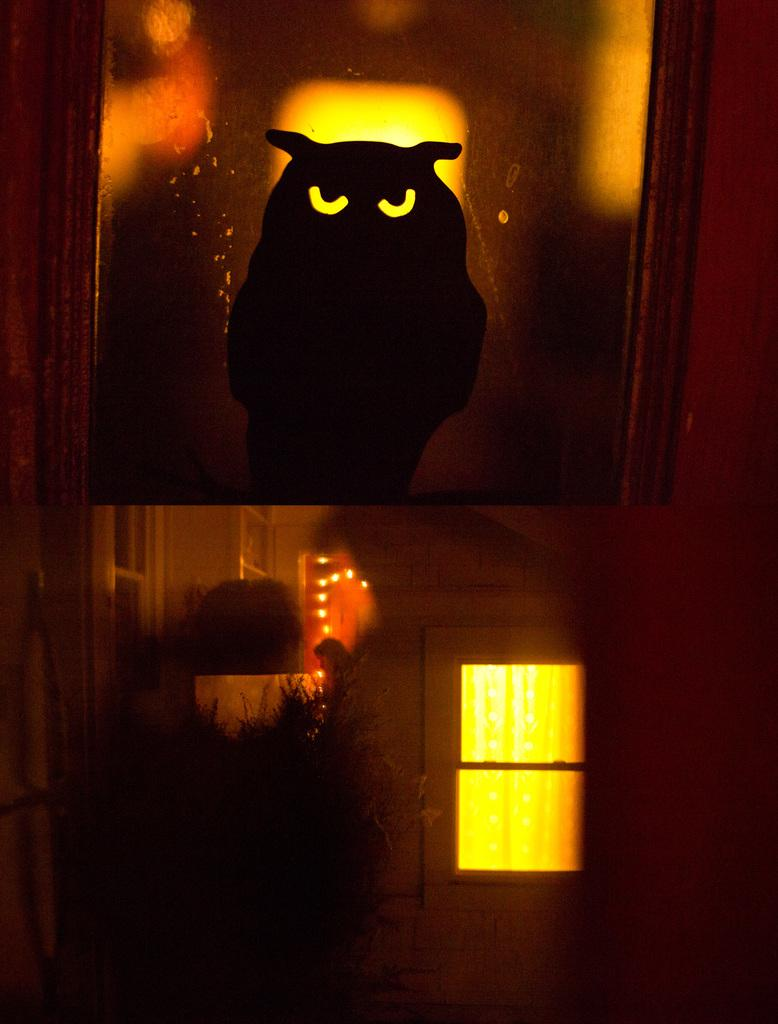What is the main structure visible in the image? There is a wall with a window in the image. What is located above the window? There is an object at the top of the image that looks like a frame. What can be seen inside the frame? Inside the frame, there is an owl. How does the owl change its color in the image? The owl does not change its color in the image; it remains the same color throughout. 